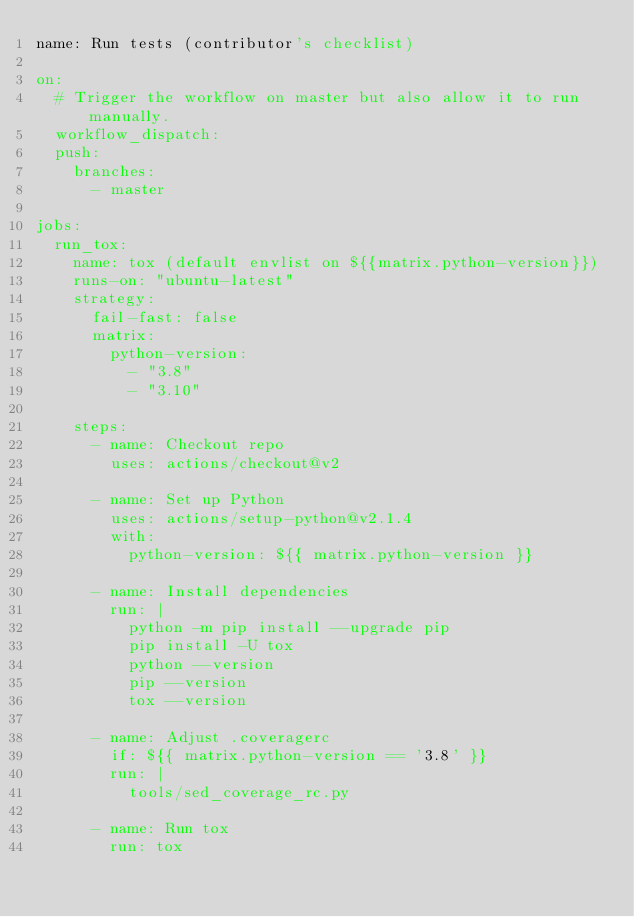Convert code to text. <code><loc_0><loc_0><loc_500><loc_500><_YAML_>name: Run tests (contributor's checklist)

on:
  # Trigger the workflow on master but also allow it to run manually.
  workflow_dispatch:
  push:
    branches:
      - master

jobs:
  run_tox:
    name: tox (default envlist on ${{matrix.python-version}})
    runs-on: "ubuntu-latest"
    strategy:
      fail-fast: false
      matrix:
        python-version:
          - "3.8"
          - "3.10"

    steps:
      - name: Checkout repo
        uses: actions/checkout@v2

      - name: Set up Python
        uses: actions/setup-python@v2.1.4
        with:
          python-version: ${{ matrix.python-version }}

      - name: Install dependencies
        run: |
          python -m pip install --upgrade pip
          pip install -U tox
          python --version
          pip --version
          tox --version

      - name: Adjust .coveragerc
        if: ${{ matrix.python-version == '3.8' }}
        run: |
          tools/sed_coverage_rc.py

      - name: Run tox
        run: tox
</code> 